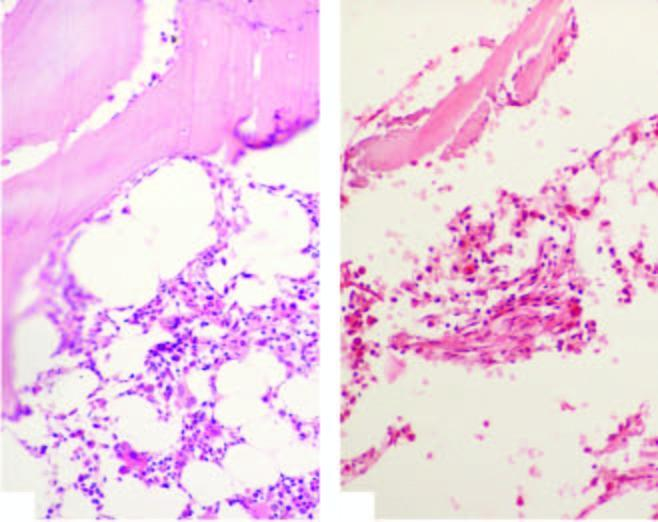what shows suppression of myeloid and erythroid cells and replacement of haematopoetic elements by fat in aplastic anaemia?
Answer the question using a single word or phrase. The biopsy 